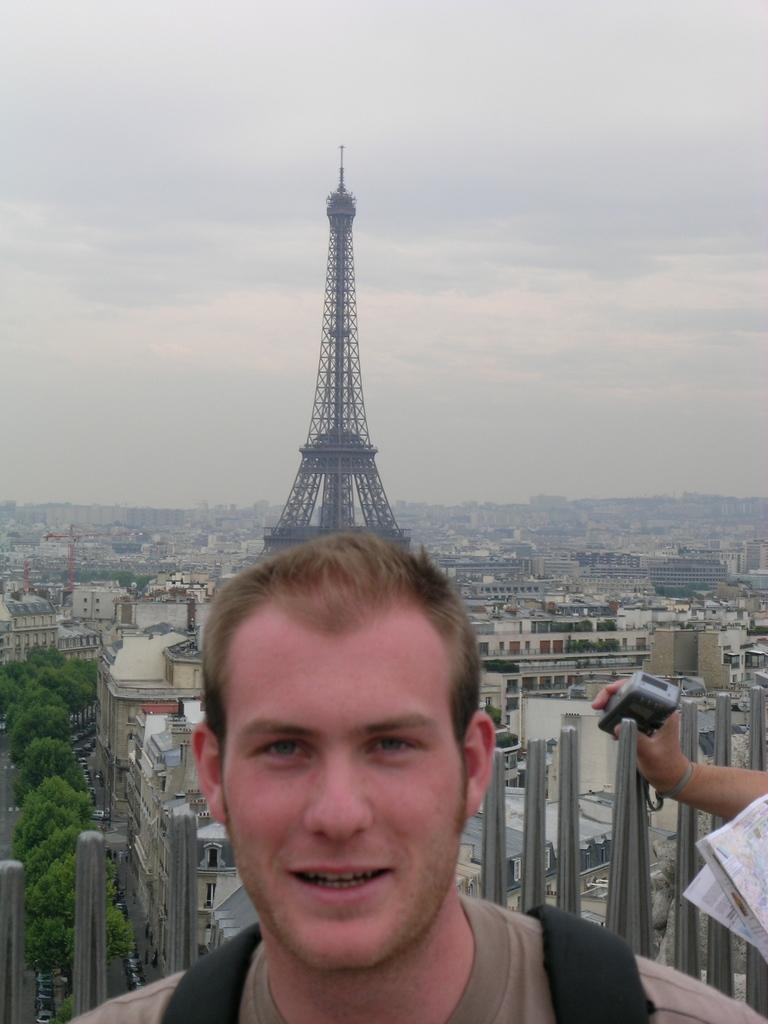Could you give a brief overview of what you see in this image? In this image we can see a person and a person´s hand holding an object and there are few rods behind the person and there are few trees, buildings, a tower and the sky in the background. 